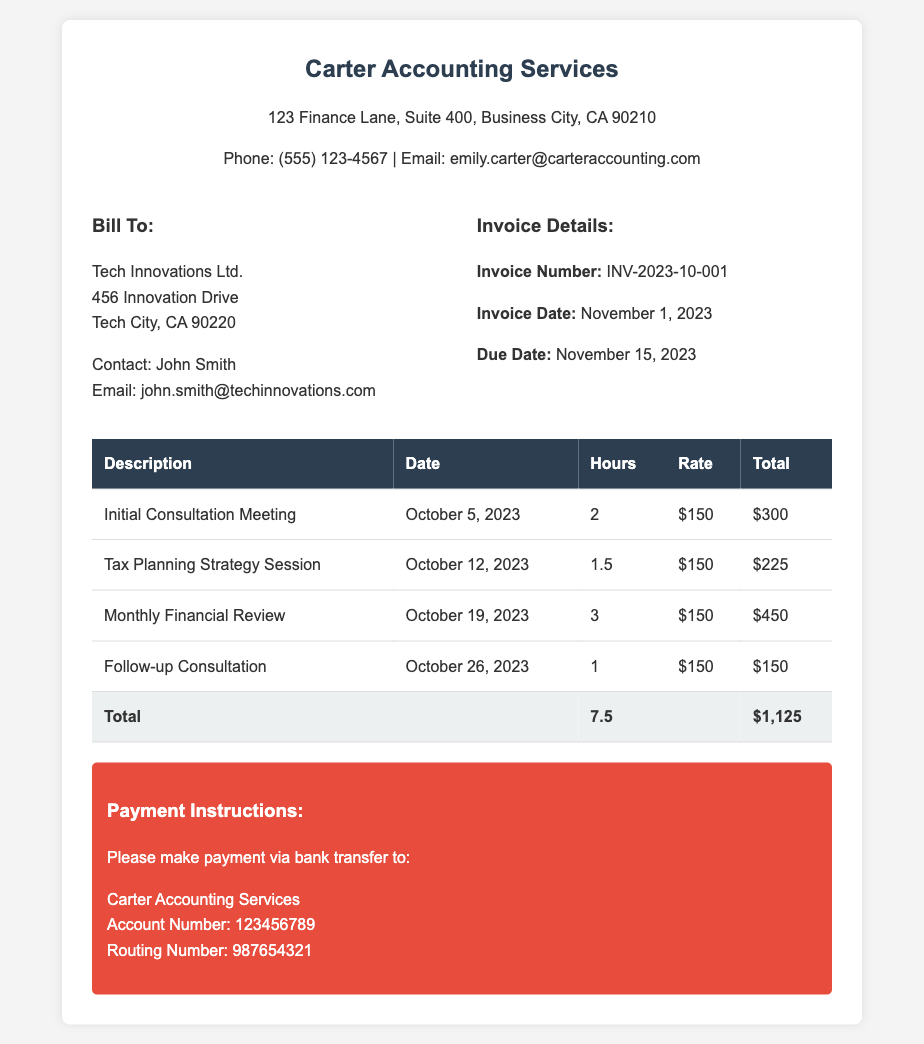What is the invoice number? The invoice number is stated in the document as a unique identifier for this billing transaction.
Answer: INV-2023-10-001 What is the total amount due? The total amount due is calculated from the total hours worked multiplied by the rate, which is summarized at the bottom of the invoice.
Answer: $1,125 Who is the contact for Tech Innovations Ltd.? This information identifies the person responsible for communications regarding the invoice and consultations.
Answer: John Smith When is the invoice due date? The due date is explicitly mentioned in the document as the deadline for payment.
Answer: November 15, 2023 How many hours were worked in total? The total hours worked is the sum of hours listed for each consultation provided in the table.
Answer: 7.5 What was the hourly rate charged? The hourly rate is consistently listed for each type of service in the invoice details.
Answer: $150 What type of service was provided on October 12, 2023? This question looks for the specific service description provided for that date in the document.
Answer: Tax Planning Strategy Session What payment method is instructed? The payment instructions specify the method through which the client should pay the invoice.
Answer: Bank transfer 